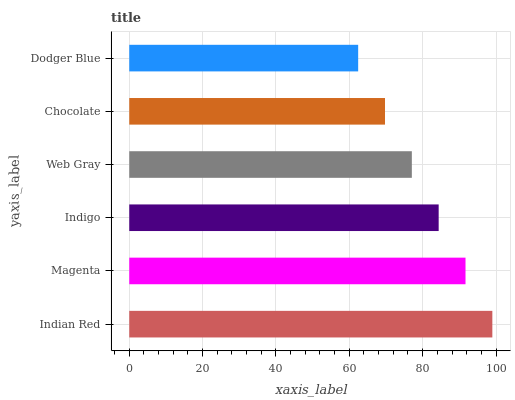Is Dodger Blue the minimum?
Answer yes or no. Yes. Is Indian Red the maximum?
Answer yes or no. Yes. Is Magenta the minimum?
Answer yes or no. No. Is Magenta the maximum?
Answer yes or no. No. Is Indian Red greater than Magenta?
Answer yes or no. Yes. Is Magenta less than Indian Red?
Answer yes or no. Yes. Is Magenta greater than Indian Red?
Answer yes or no. No. Is Indian Red less than Magenta?
Answer yes or no. No. Is Indigo the high median?
Answer yes or no. Yes. Is Web Gray the low median?
Answer yes or no. Yes. Is Indian Red the high median?
Answer yes or no. No. Is Dodger Blue the low median?
Answer yes or no. No. 